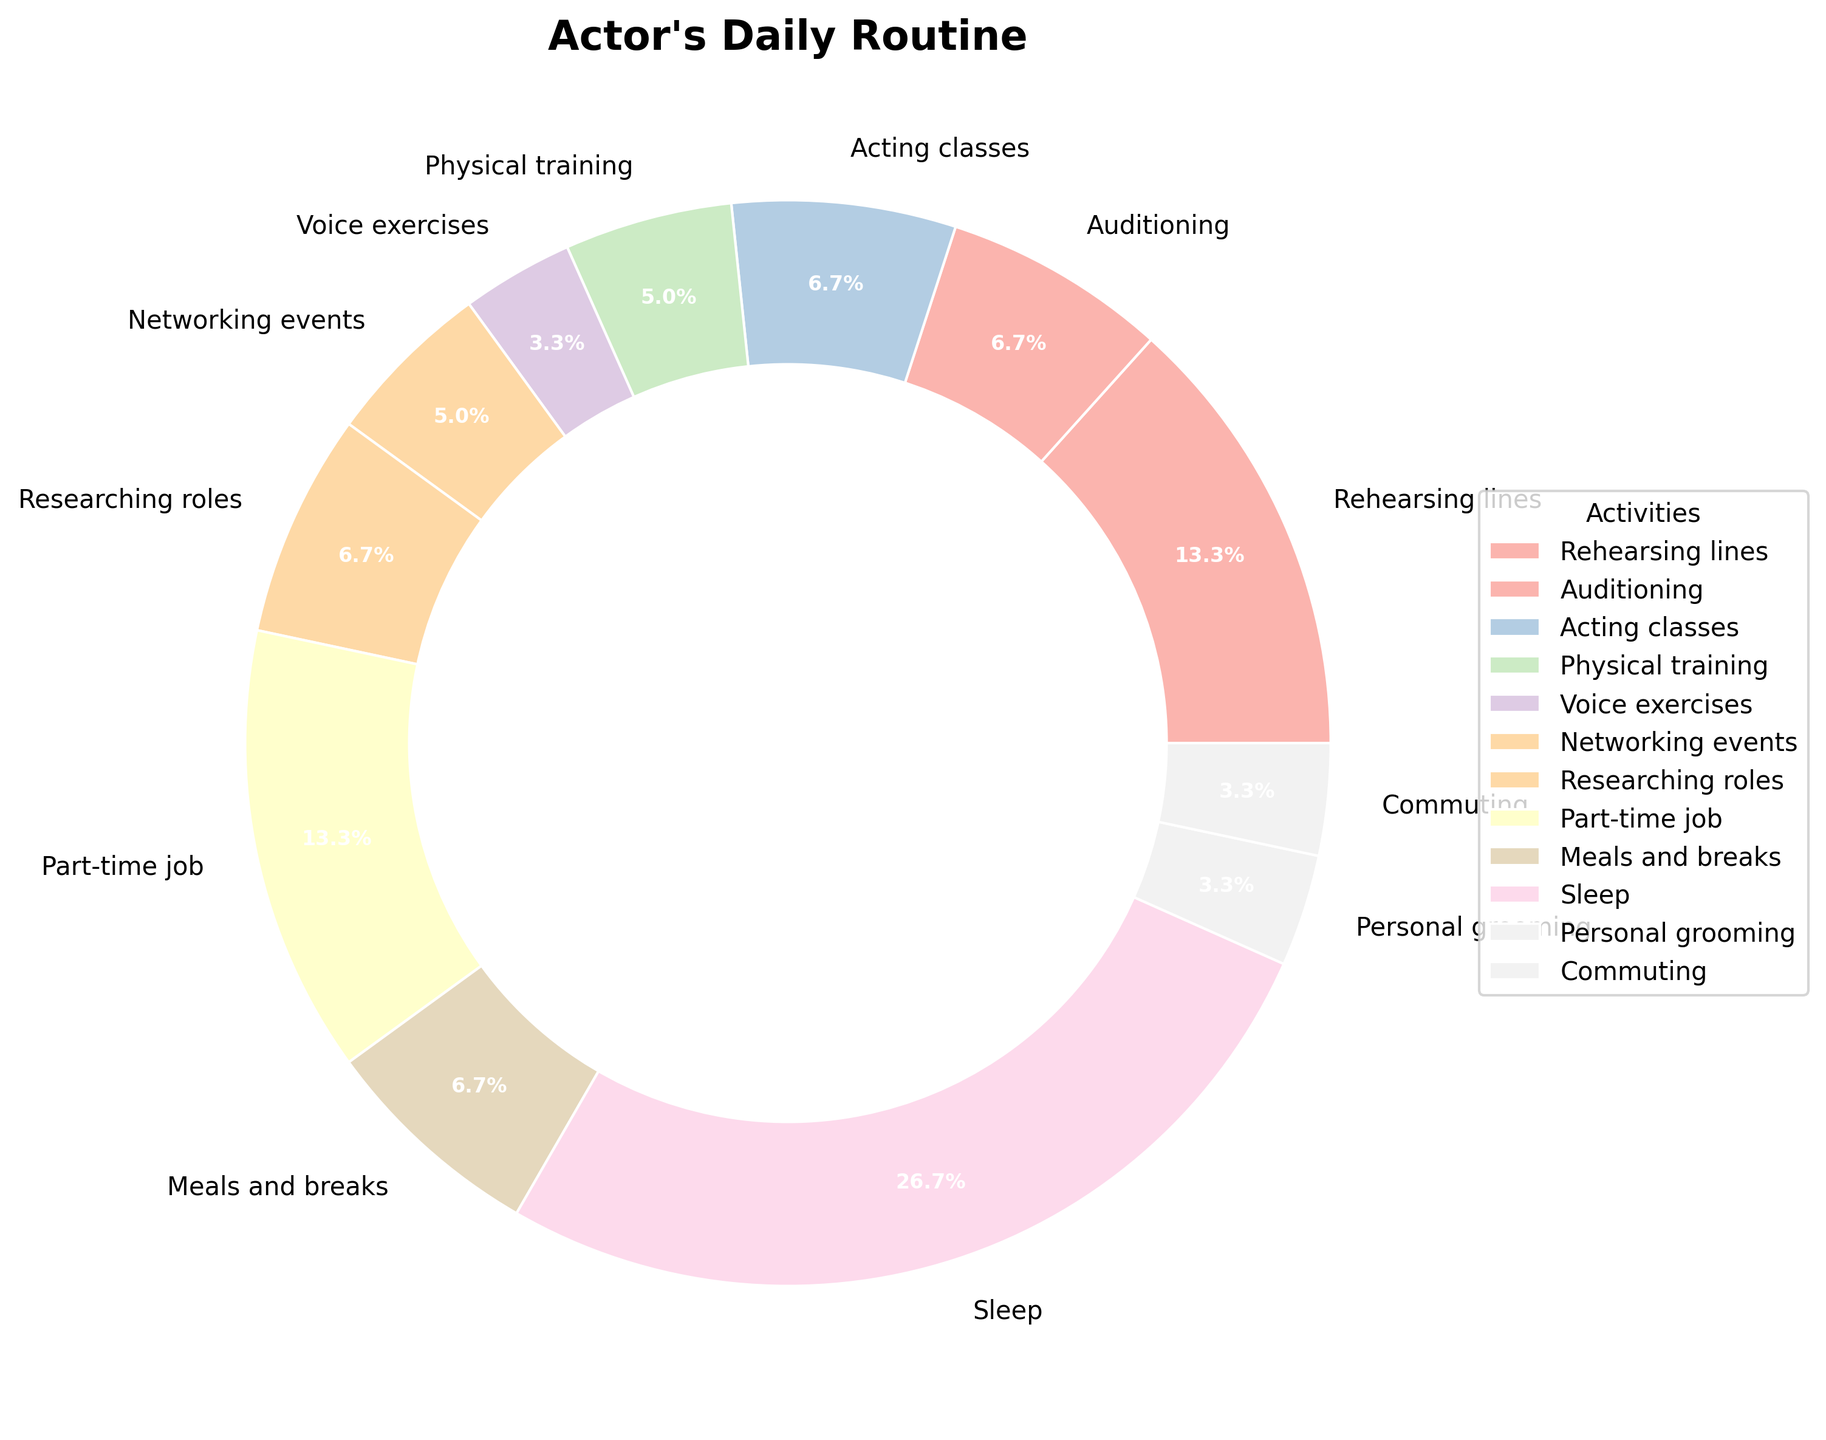Which activity takes the largest portion of the actor's daily routine? By examining the pie chart, it can be seen that the slice representing "Sleep" occupies the most significant portion of the chart.
Answer: Sleep Which two activities take up the same amount of time in the actor's daily routine? Observing the pie chart, the slices for "Auditioning" and "Acting classes" are the same size, each taking up 2 hours.
Answer: Auditioning and Acting classes How much combined time is spent on physical training and voice exercises? From the chart, physical training takes 1.5 hours and voice exercises take 1 hour. Adding them together, the total time is 1.5 + 1 = 2.5 hours.
Answer: 2.5 hours Which activity takes less time, networking events or researching roles? By comparing the slices, "Networking events" takes 1.5 hours while "Researching roles" takes 2 hours. Thus, networking events take less time.
Answer: Networking events What percentage of the day is spent on the part-time job and personal grooming combined? The part-time job takes 4 hours and personal grooming takes 1 hour. Adding them, we get 4 + 1 = 5 hours. Considering there are 24 hours in a day, the percentage is (5 / 24) * 100 ≈ 20.8%.
Answer: 20.8% How does the time spent on meals and breaks compare to the time spent commuting? Referring to the pie chart, the "Meals and breaks" segment is 2 hours, and the "Commuting" segment is 1 hour. Therefore, meals and breaks take twice as much time as commuting.
Answer: Meals and breaks take twice as much time Calculate the total time spent on rehearsing lines, auditioning, and researching roles. Rehearsing lines takes 4 hours, auditioning takes 2 hours, and researching roles takes 2 hours. Summing these, 4 + 2 + 2 = 8 hours.
Answer: 8 hours What is the difference in time allocation between personal grooming and voice exercises? The slice for personal grooming represents 1 hour, while the slice for voice exercises also represents 1 hour. Thus, the difference in time allocation is 1 - 1 = 0 hours.
Answer: 0 hours Which color represents the activity "Network Events" in the pie chart? Looking at the color legend or the visual chart itself, we can identify the color associated with "Networking events".
Answer: Pale green (or the specific color if more precisely identified in the chart) If the actor were to spend an additional hour each day on acting classes, how would that impact his daily schedule in terms of hours spent? Originally, acting classes take 2 hours. Adding an additional hour means the actor would now spend 2 + 1 = 3 hours on acting classes. This would increase the total hours to 25 hours, which is beyond 24 hours usually available in a day, indicating a need for reallocation.
Answer: 3 hours on acting classes and a need to reallocate activities 